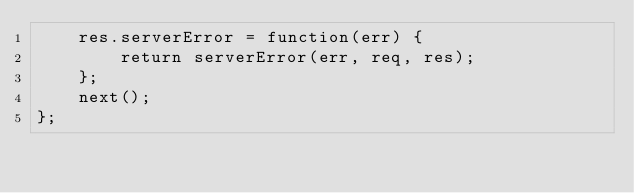<code> <loc_0><loc_0><loc_500><loc_500><_JavaScript_>	res.serverError = function(err) {
		return serverError(err, req, res);
	};
	next();
};
</code> 